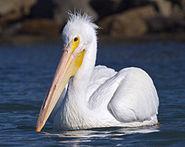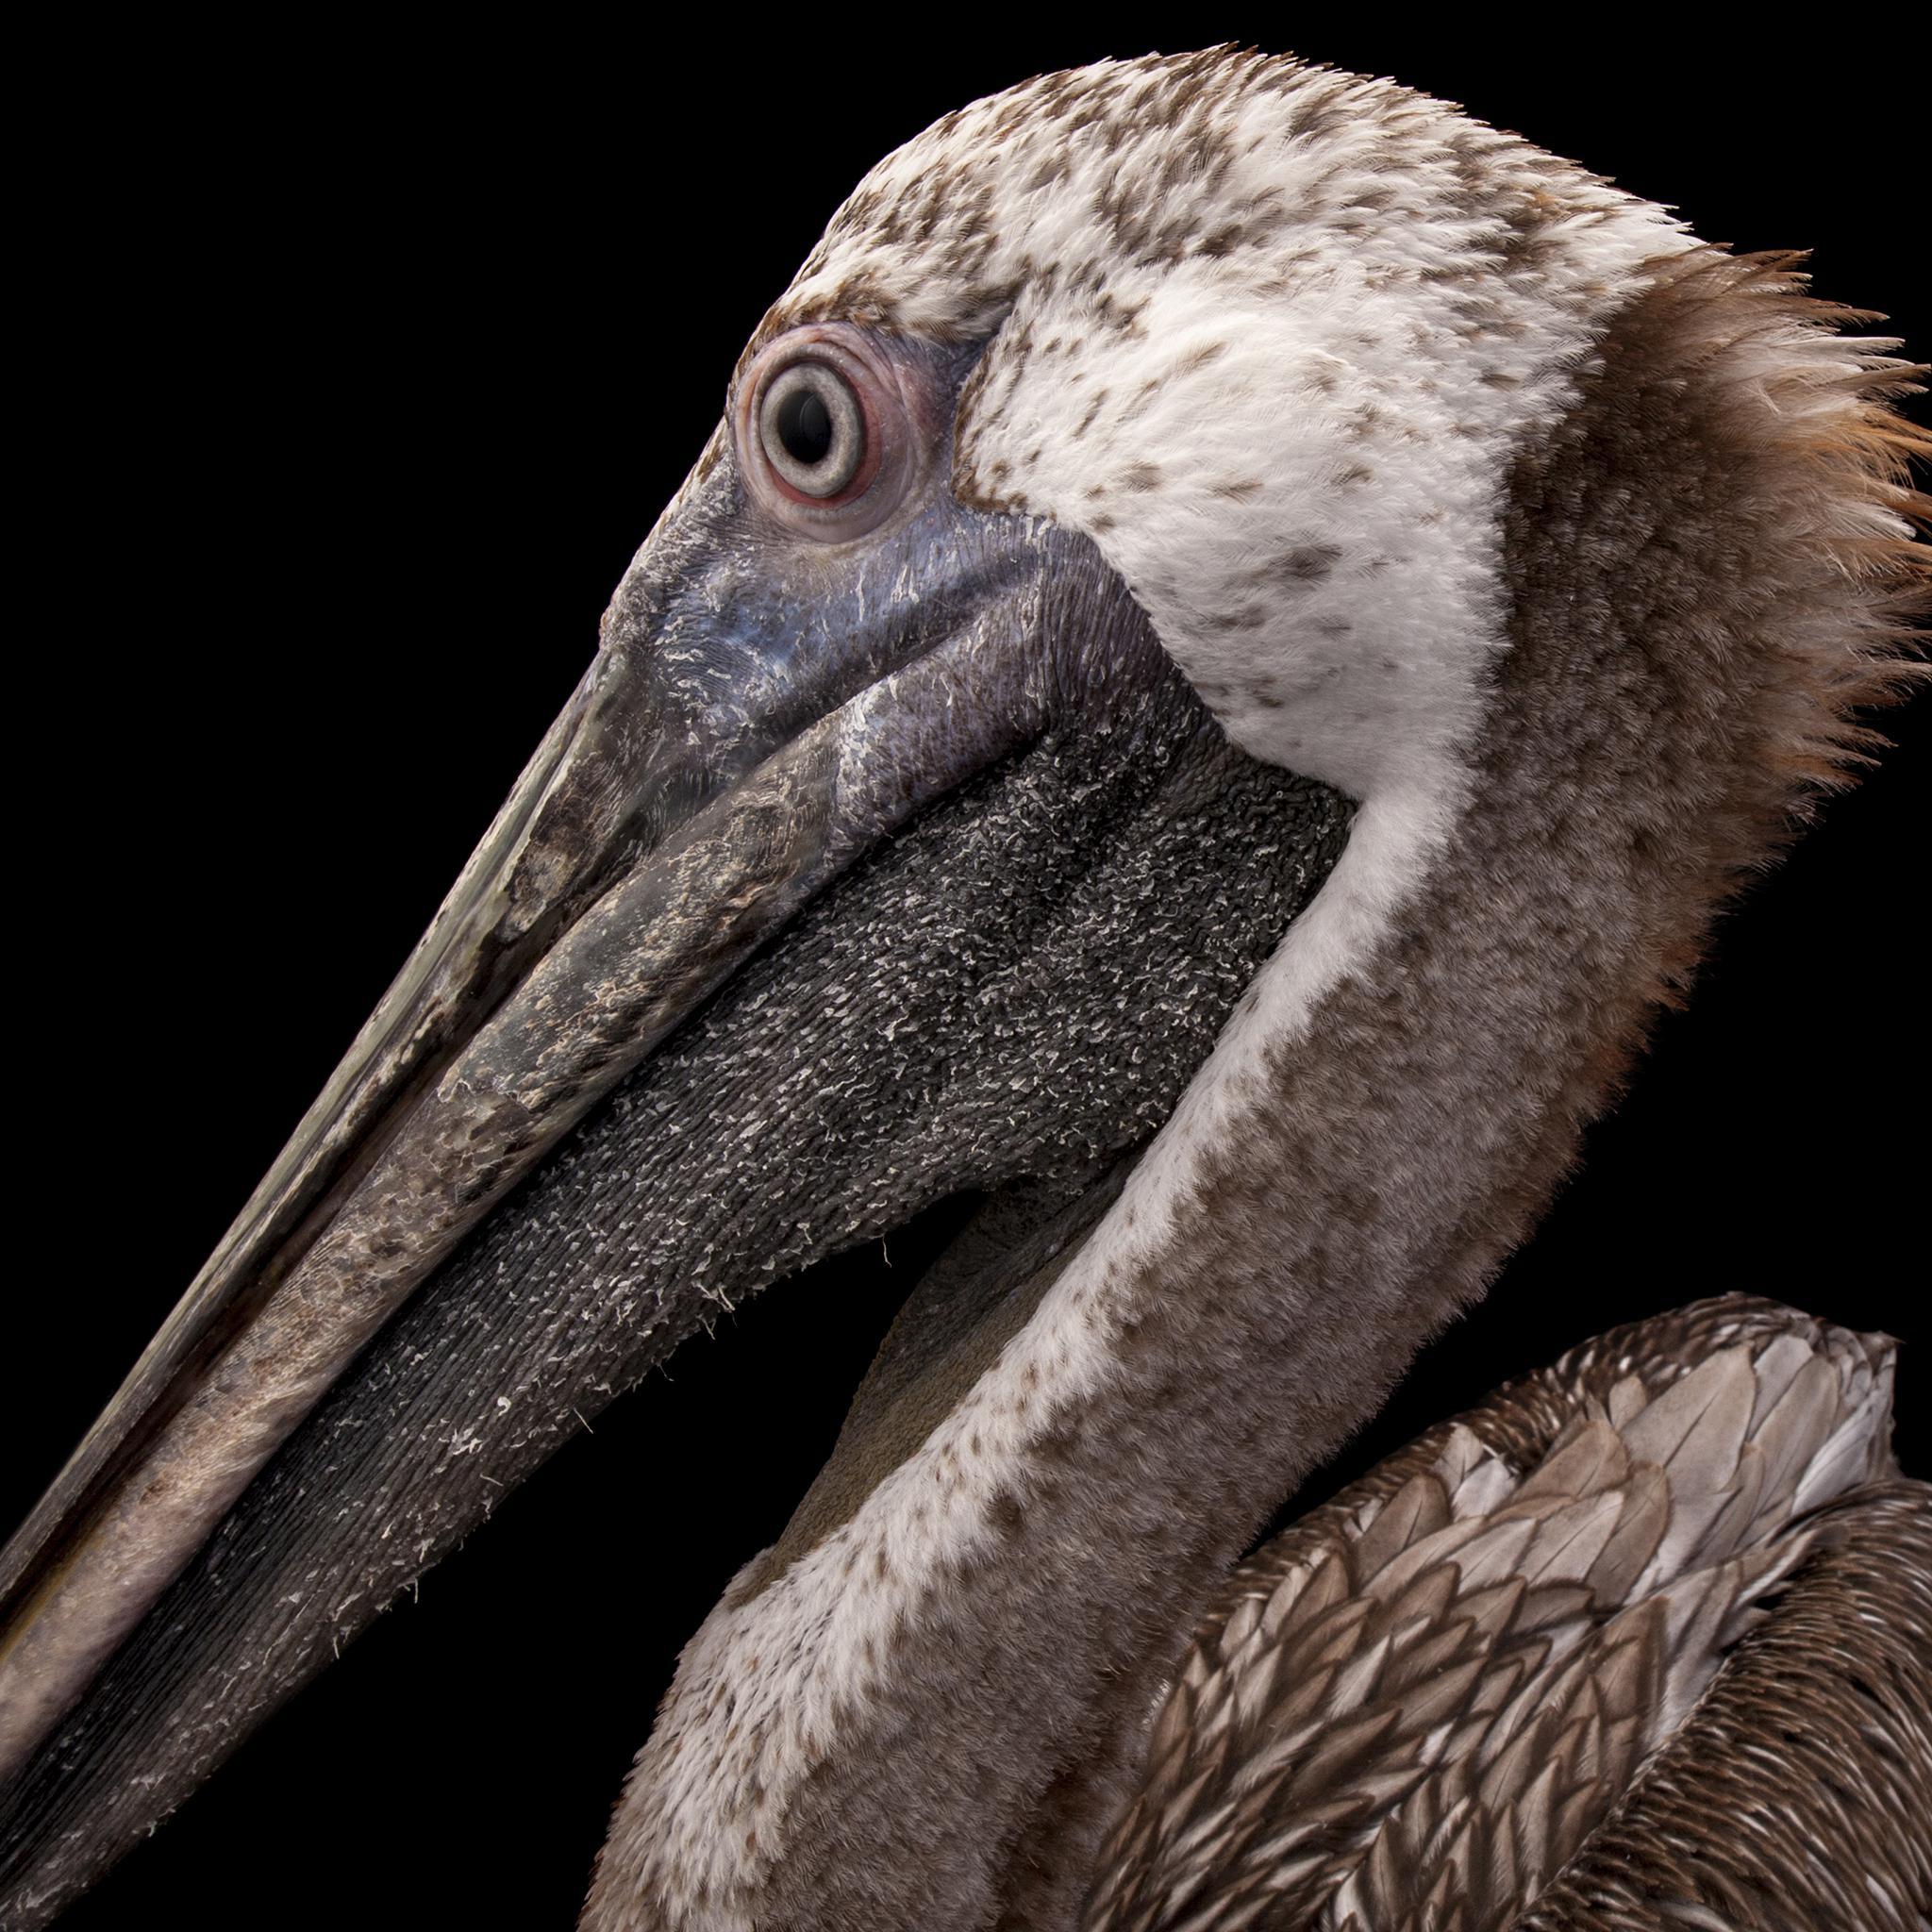The first image is the image on the left, the second image is the image on the right. Analyze the images presented: Is the assertion "An image shows a leftward floating pelican with a fish in its bill." valid? Answer yes or no. No. The first image is the image on the left, the second image is the image on the right. Evaluate the accuracy of this statement regarding the images: "The bird in the left image is facing towards the left.". Is it true? Answer yes or no. Yes. 